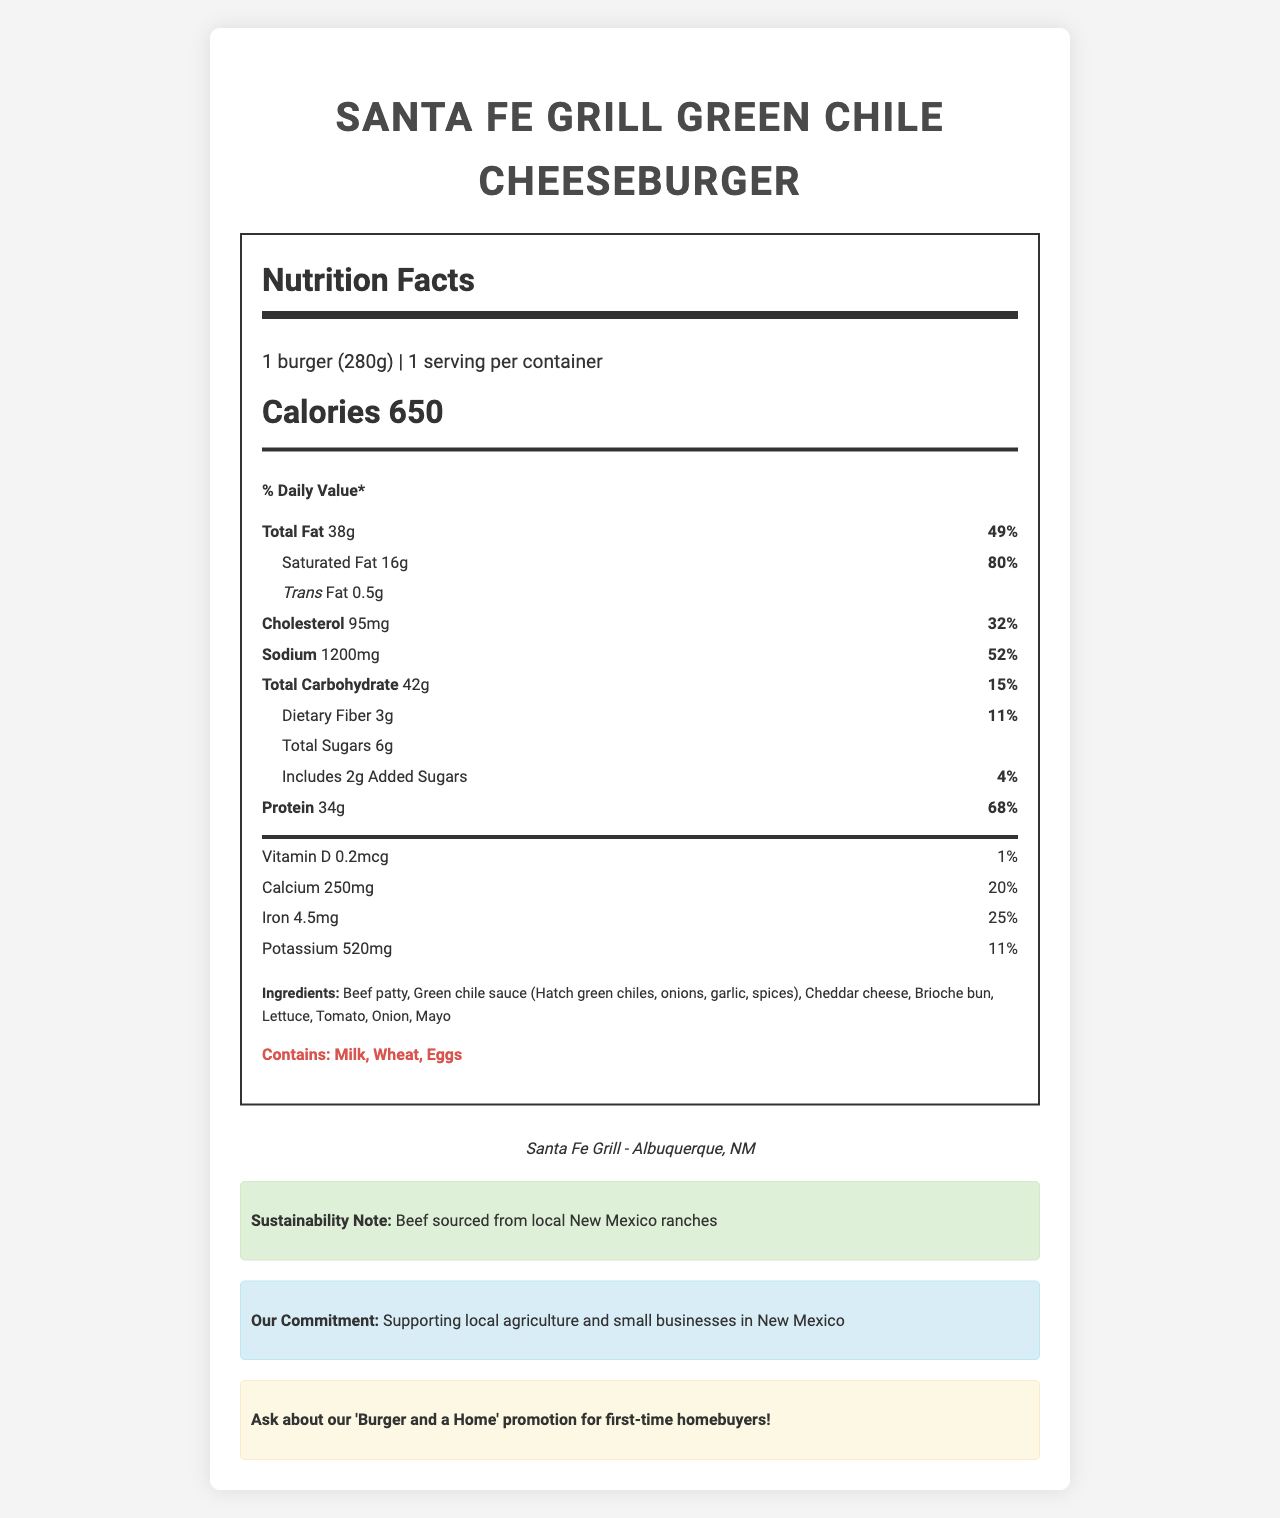what is the serving size? The serving size is directly stated at the beginning of the Nutrition Facts label.
Answer: 1 burger (280g) how many calories does the green chile cheeseburger contain? The Nutrition Facts section lists the calories as 650.
Answer: 650 what percentage of the daily value of total fat does one serving provide? The document states that the total fat daily value percentage is 49%.
Answer: 49% what are the main ingredients in the green chile cheeseburger? The ingredients are listed towards the end of the nutrition facts section.
Answer: Beef patty, Green chile sauce, Cheddar cheese, Brioche bun, Lettuce, Tomato, Onion, Mayo how much protein does one green chile cheeseburger contain? The protein content is listed as 34 grams in the nutrition facts.
Answer: 34g what is the daily value percentage for cholesterol in this burger? The daily value percentage for cholesterol is noted as 32%.
Answer: 32% what is the sodium content of the burger? The sodium content is listed as 1200 milligrams.
Answer: 1200mg which of the following allergens are present in the burger? A. Milk B. Nuts C. Wheat D. Peanuts The document lists milk and wheat as allergens.
Answer: A and C how many grams of saturated fat are present in the burger? A. 10g B. 14g C. 16g D. 18g The saturated fat amount is listed as 16 grams.
Answer: C does the burger contain added sugars? The document lists that the burger includes 2 grams of added sugars.
Answer: Yes is the green chile cheeseburger suitable for someone with a dairy allergy? The burger contains milk, as indicated in the allergens section.
Answer: No describe the main points presented in the nutrition facts document for the green chile cheeseburger from Santa Fe Grill. The explanation involves summarizing the entire nutritional profile, key components, sustainability note, political statement, and the real estate promotion mentioned in the document.
Answer: The document provides detailed nutritional information for a green chile cheeseburger from Santa Fe Grill, listing serving size, calorie content, and percentages of daily values for fats, cholesterol, sodium, carbohydrates, protein, vitamins, and minerals. It also includes ingredient details, allergens, and notes on sustainability, political support for local agriculture, and a real estate promotion. what is the exact amount of vitamin C in the burger? The document provides information on vitamin D, calcium, iron, and potassium but does not list the vitamin C content.
Answer: Not enough information 